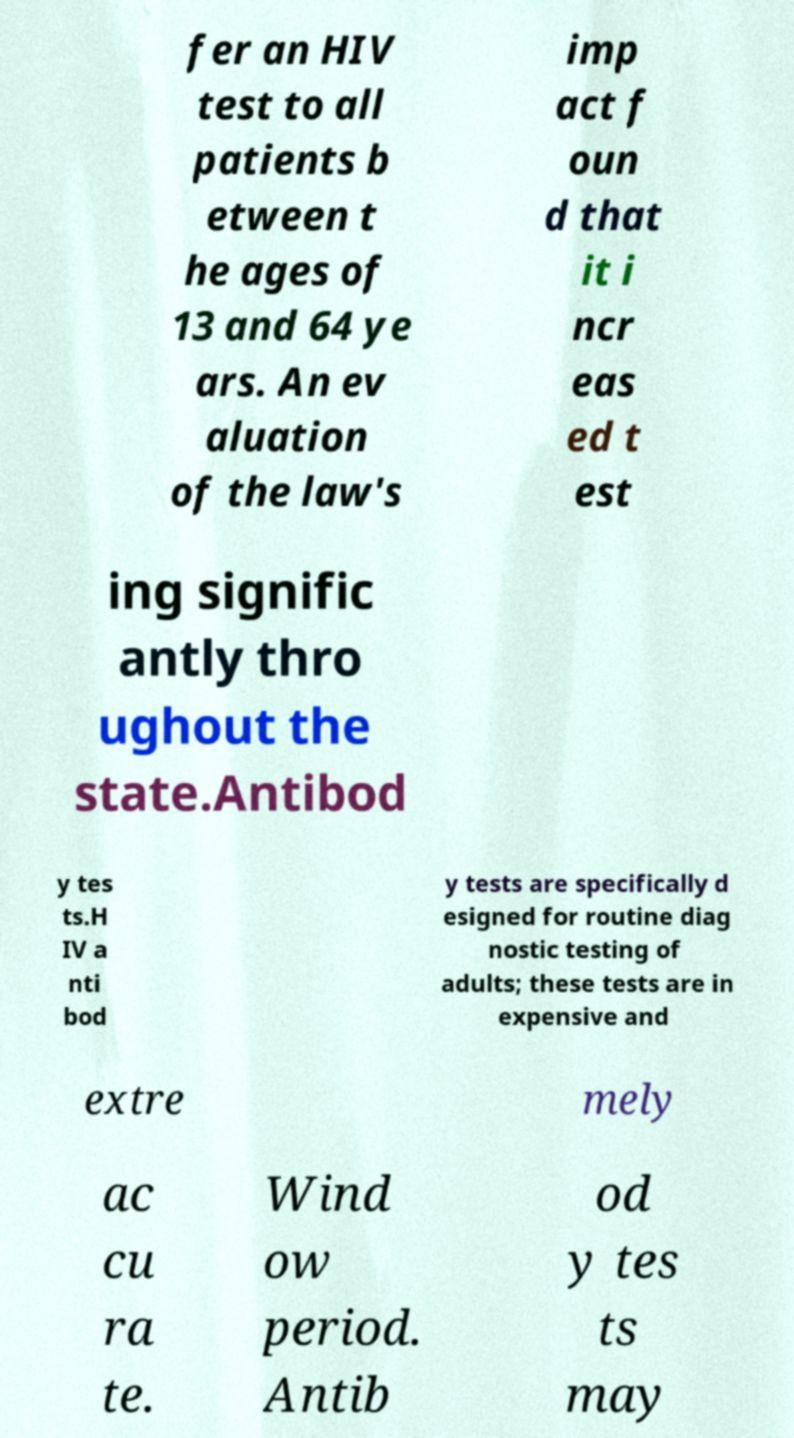There's text embedded in this image that I need extracted. Can you transcribe it verbatim? fer an HIV test to all patients b etween t he ages of 13 and 64 ye ars. An ev aluation of the law's imp act f oun d that it i ncr eas ed t est ing signific antly thro ughout the state.Antibod y tes ts.H IV a nti bod y tests are specifically d esigned for routine diag nostic testing of adults; these tests are in expensive and extre mely ac cu ra te. Wind ow period. Antib od y tes ts may 